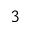Convert formula to latex. <formula><loc_0><loc_0><loc_500><loc_500>^ { 3 }</formula> 